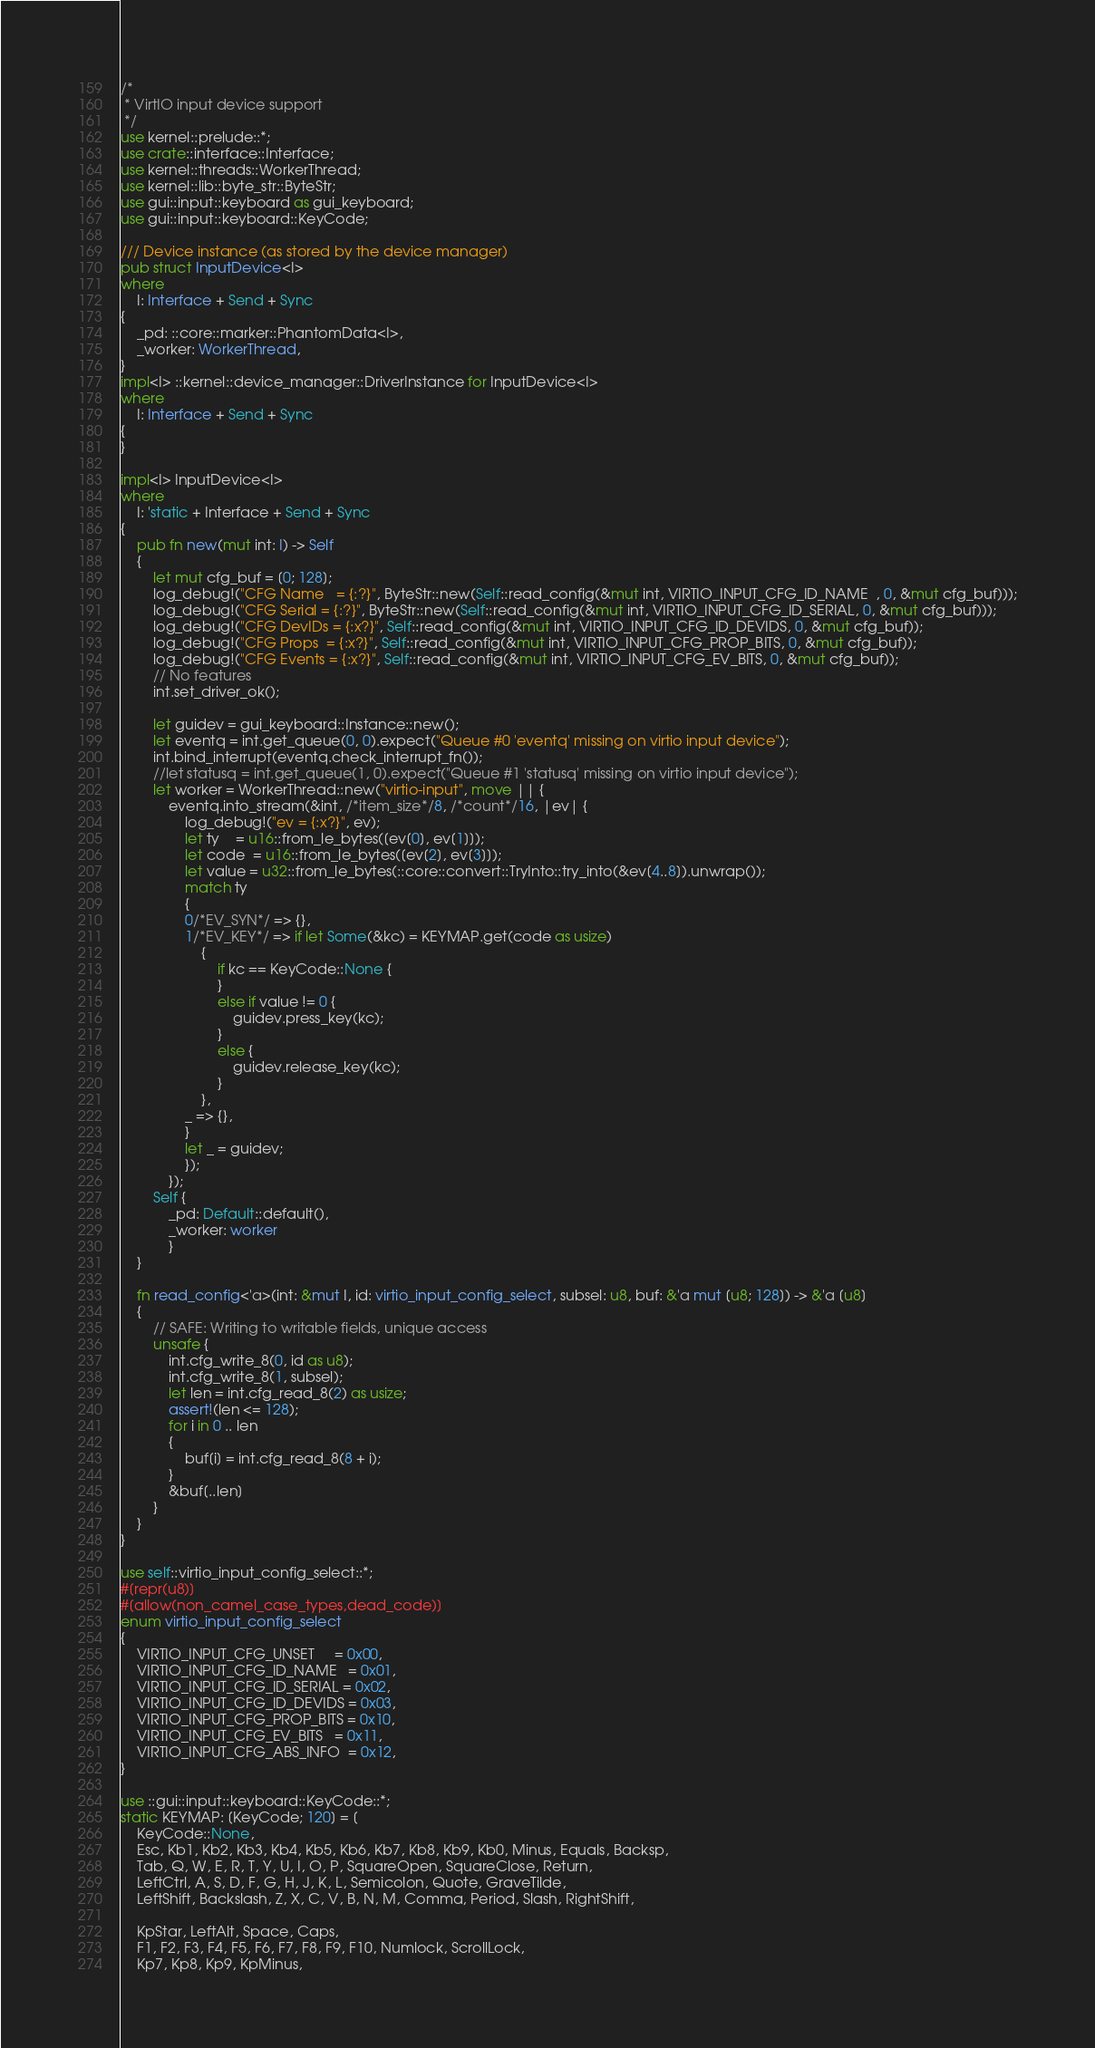Convert code to text. <code><loc_0><loc_0><loc_500><loc_500><_Rust_>/*
 * VirtIO input device support
 */
use kernel::prelude::*;
use crate::interface::Interface;
use kernel::threads::WorkerThread;
use kernel::lib::byte_str::ByteStr;
use gui::input::keyboard as gui_keyboard;
use gui::input::keyboard::KeyCode;

/// Device instance (as stored by the device manager)
pub struct InputDevice<I>
where
	I: Interface + Send + Sync
{
	_pd: ::core::marker::PhantomData<I>,
	_worker: WorkerThread,
}
impl<I> ::kernel::device_manager::DriverInstance for InputDevice<I>
where
	I: Interface + Send + Sync
{
}

impl<I> InputDevice<I>
where
	I: 'static + Interface + Send + Sync
{
	pub fn new(mut int: I) -> Self
	{
		let mut cfg_buf = [0; 128];
		log_debug!("CFG Name   = {:?}", ByteStr::new(Self::read_config(&mut int, VIRTIO_INPUT_CFG_ID_NAME  , 0, &mut cfg_buf)));
		log_debug!("CFG Serial = {:?}", ByteStr::new(Self::read_config(&mut int, VIRTIO_INPUT_CFG_ID_SERIAL, 0, &mut cfg_buf)));
		log_debug!("CFG DevIDs = {:x?}", Self::read_config(&mut int, VIRTIO_INPUT_CFG_ID_DEVIDS, 0, &mut cfg_buf));
		log_debug!("CFG Props  = {:x?}", Self::read_config(&mut int, VIRTIO_INPUT_CFG_PROP_BITS, 0, &mut cfg_buf));
		log_debug!("CFG Events = {:x?}", Self::read_config(&mut int, VIRTIO_INPUT_CFG_EV_BITS, 0, &mut cfg_buf));
		// No features
		int.set_driver_ok();

		let guidev = gui_keyboard::Instance::new();
		let eventq = int.get_queue(0, 0).expect("Queue #0 'eventq' missing on virtio input device");
		int.bind_interrupt(eventq.check_interrupt_fn());
		//let statusq = int.get_queue(1, 0).expect("Queue #1 'statusq' missing on virtio input device");
		let worker = WorkerThread::new("virtio-input", move || {
			eventq.into_stream(&int, /*item_size*/8, /*count*/16, |ev| {
				log_debug!("ev = {:x?}", ev);
				let ty    = u16::from_le_bytes([ev[0], ev[1]]);
				let code  = u16::from_le_bytes([ev[2], ev[3]]);
				let value = u32::from_le_bytes(::core::convert::TryInto::try_into(&ev[4..8]).unwrap());
				match ty
				{
				0/*EV_SYN*/ => {},
				1/*EV_KEY*/ => if let Some(&kc) = KEYMAP.get(code as usize)
					{
						if kc == KeyCode::None {
						}
						else if value != 0 {
							guidev.press_key(kc);
						}
						else {
							guidev.release_key(kc);
						}
					},
				_ => {},
				}
				let _ = guidev;
				});
			});
		Self {
			_pd: Default::default(),
			_worker: worker
			}
	}

	fn read_config<'a>(int: &mut I, id: virtio_input_config_select, subsel: u8, buf: &'a mut [u8; 128]) -> &'a [u8]
	{
		// SAFE: Writing to writable fields, unique access
		unsafe {
			int.cfg_write_8(0, id as u8);
			int.cfg_write_8(1, subsel);
			let len = int.cfg_read_8(2) as usize;
			assert!(len <= 128);
			for i in 0 .. len
			{
				buf[i] = int.cfg_read_8(8 + i);
			}
			&buf[..len]
		}
	}
}

use self::virtio_input_config_select::*;
#[repr(u8)]
#[allow(non_camel_case_types,dead_code)]
enum virtio_input_config_select
{
	VIRTIO_INPUT_CFG_UNSET     = 0x00,
	VIRTIO_INPUT_CFG_ID_NAME   = 0x01,
	VIRTIO_INPUT_CFG_ID_SERIAL = 0x02,
	VIRTIO_INPUT_CFG_ID_DEVIDS = 0x03,
	VIRTIO_INPUT_CFG_PROP_BITS = 0x10,
	VIRTIO_INPUT_CFG_EV_BITS   = 0x11,
	VIRTIO_INPUT_CFG_ABS_INFO  = 0x12,
}

use ::gui::input::keyboard::KeyCode::*;
static KEYMAP: [KeyCode; 120] = [
	KeyCode::None,
	Esc, Kb1, Kb2, Kb3, Kb4, Kb5, Kb6, Kb7, Kb8, Kb9, Kb0, Minus, Equals, Backsp,
	Tab, Q, W, E, R, T, Y, U, I, O, P, SquareOpen, SquareClose, Return,
	LeftCtrl, A, S, D, F, G, H, J, K, L, Semicolon, Quote, GraveTilde,
	LeftShift, Backslash, Z, X, C, V, B, N, M, Comma, Period, Slash, RightShift,

	KpStar, LeftAlt, Space, Caps,
	F1, F2, F3, F4, F5, F6, F7, F8, F9, F10, Numlock, ScrollLock,
	Kp7, Kp8, Kp9, KpMinus,</code> 